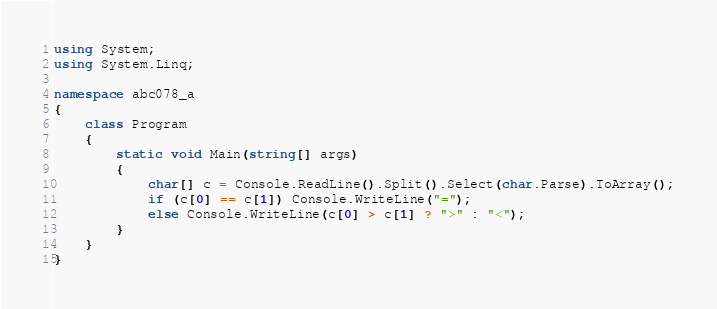Convert code to text. <code><loc_0><loc_0><loc_500><loc_500><_C#_>using System;
using System.Linq;

namespace abc078_a
{
    class Program
    {
        static void Main(string[] args)
        {
            char[] c = Console.ReadLine().Split().Select(char.Parse).ToArray();
            if (c[0] == c[1]) Console.WriteLine("=");
            else Console.WriteLine(c[0] > c[1] ? ">" : "<");
        }
    }
}</code> 